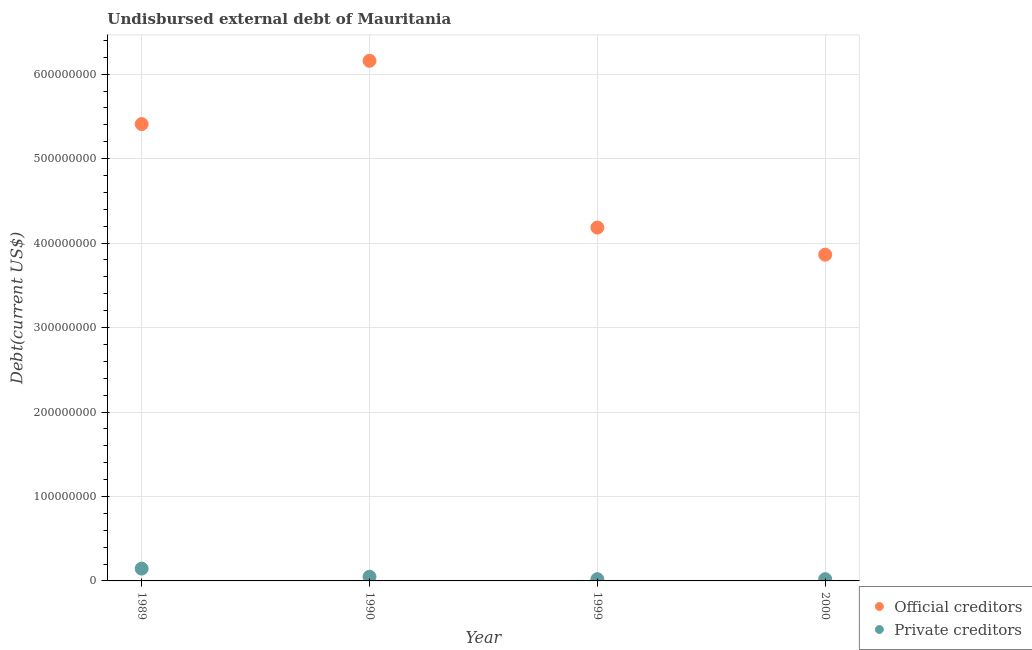Is the number of dotlines equal to the number of legend labels?
Your response must be concise. Yes. What is the undisbursed external debt of private creditors in 1989?
Provide a succinct answer. 1.46e+07. Across all years, what is the maximum undisbursed external debt of official creditors?
Provide a short and direct response. 6.16e+08. Across all years, what is the minimum undisbursed external debt of private creditors?
Give a very brief answer. 2.08e+06. In which year was the undisbursed external debt of private creditors maximum?
Ensure brevity in your answer.  1989. In which year was the undisbursed external debt of official creditors minimum?
Your answer should be very brief. 2000. What is the total undisbursed external debt of official creditors in the graph?
Give a very brief answer. 1.96e+09. What is the difference between the undisbursed external debt of private creditors in 1999 and that in 2000?
Keep it short and to the point. 0. What is the difference between the undisbursed external debt of private creditors in 1999 and the undisbursed external debt of official creditors in 2000?
Your answer should be compact. -3.84e+08. What is the average undisbursed external debt of official creditors per year?
Make the answer very short. 4.90e+08. In the year 1989, what is the difference between the undisbursed external debt of official creditors and undisbursed external debt of private creditors?
Give a very brief answer. 5.26e+08. In how many years, is the undisbursed external debt of private creditors greater than 280000000 US$?
Your response must be concise. 0. What is the ratio of the undisbursed external debt of official creditors in 1989 to that in 1999?
Provide a succinct answer. 1.29. Is the difference between the undisbursed external debt of official creditors in 1989 and 2000 greater than the difference between the undisbursed external debt of private creditors in 1989 and 2000?
Make the answer very short. Yes. What is the difference between the highest and the second highest undisbursed external debt of official creditors?
Offer a terse response. 7.49e+07. What is the difference between the highest and the lowest undisbursed external debt of official creditors?
Make the answer very short. 2.30e+08. In how many years, is the undisbursed external debt of private creditors greater than the average undisbursed external debt of private creditors taken over all years?
Keep it short and to the point. 1. Is the sum of the undisbursed external debt of official creditors in 1989 and 1999 greater than the maximum undisbursed external debt of private creditors across all years?
Make the answer very short. Yes. Is the undisbursed external debt of official creditors strictly greater than the undisbursed external debt of private creditors over the years?
Your answer should be compact. Yes. How many years are there in the graph?
Your answer should be very brief. 4. What is the difference between two consecutive major ticks on the Y-axis?
Provide a short and direct response. 1.00e+08. Where does the legend appear in the graph?
Your answer should be very brief. Bottom right. What is the title of the graph?
Give a very brief answer. Undisbursed external debt of Mauritania. Does "Fertility rate" appear as one of the legend labels in the graph?
Your answer should be very brief. No. What is the label or title of the Y-axis?
Your answer should be compact. Debt(current US$). What is the Debt(current US$) in Official creditors in 1989?
Your answer should be very brief. 5.41e+08. What is the Debt(current US$) in Private creditors in 1989?
Keep it short and to the point. 1.46e+07. What is the Debt(current US$) in Official creditors in 1990?
Offer a terse response. 6.16e+08. What is the Debt(current US$) of Private creditors in 1990?
Provide a short and direct response. 4.95e+06. What is the Debt(current US$) of Official creditors in 1999?
Your answer should be very brief. 4.18e+08. What is the Debt(current US$) of Private creditors in 1999?
Your answer should be compact. 2.08e+06. What is the Debt(current US$) in Official creditors in 2000?
Offer a terse response. 3.86e+08. What is the Debt(current US$) in Private creditors in 2000?
Ensure brevity in your answer.  2.08e+06. Across all years, what is the maximum Debt(current US$) of Official creditors?
Your answer should be very brief. 6.16e+08. Across all years, what is the maximum Debt(current US$) in Private creditors?
Your answer should be compact. 1.46e+07. Across all years, what is the minimum Debt(current US$) of Official creditors?
Offer a very short reply. 3.86e+08. Across all years, what is the minimum Debt(current US$) in Private creditors?
Your answer should be compact. 2.08e+06. What is the total Debt(current US$) in Official creditors in the graph?
Your answer should be very brief. 1.96e+09. What is the total Debt(current US$) of Private creditors in the graph?
Your answer should be very brief. 2.37e+07. What is the difference between the Debt(current US$) of Official creditors in 1989 and that in 1990?
Ensure brevity in your answer.  -7.49e+07. What is the difference between the Debt(current US$) in Private creditors in 1989 and that in 1990?
Make the answer very short. 9.63e+06. What is the difference between the Debt(current US$) in Official creditors in 1989 and that in 1999?
Provide a succinct answer. 1.23e+08. What is the difference between the Debt(current US$) in Private creditors in 1989 and that in 1999?
Keep it short and to the point. 1.25e+07. What is the difference between the Debt(current US$) in Official creditors in 1989 and that in 2000?
Offer a very short reply. 1.55e+08. What is the difference between the Debt(current US$) of Private creditors in 1989 and that in 2000?
Provide a short and direct response. 1.25e+07. What is the difference between the Debt(current US$) in Official creditors in 1990 and that in 1999?
Make the answer very short. 1.97e+08. What is the difference between the Debt(current US$) of Private creditors in 1990 and that in 1999?
Your answer should be very brief. 2.86e+06. What is the difference between the Debt(current US$) in Official creditors in 1990 and that in 2000?
Make the answer very short. 2.30e+08. What is the difference between the Debt(current US$) of Private creditors in 1990 and that in 2000?
Provide a short and direct response. 2.86e+06. What is the difference between the Debt(current US$) in Official creditors in 1999 and that in 2000?
Give a very brief answer. 3.21e+07. What is the difference between the Debt(current US$) in Official creditors in 1989 and the Debt(current US$) in Private creditors in 1990?
Ensure brevity in your answer.  5.36e+08. What is the difference between the Debt(current US$) of Official creditors in 1989 and the Debt(current US$) of Private creditors in 1999?
Make the answer very short. 5.39e+08. What is the difference between the Debt(current US$) of Official creditors in 1989 and the Debt(current US$) of Private creditors in 2000?
Your response must be concise. 5.39e+08. What is the difference between the Debt(current US$) in Official creditors in 1990 and the Debt(current US$) in Private creditors in 1999?
Your response must be concise. 6.14e+08. What is the difference between the Debt(current US$) of Official creditors in 1990 and the Debt(current US$) of Private creditors in 2000?
Your answer should be very brief. 6.14e+08. What is the difference between the Debt(current US$) of Official creditors in 1999 and the Debt(current US$) of Private creditors in 2000?
Provide a short and direct response. 4.16e+08. What is the average Debt(current US$) in Official creditors per year?
Offer a very short reply. 4.90e+08. What is the average Debt(current US$) in Private creditors per year?
Give a very brief answer. 5.92e+06. In the year 1989, what is the difference between the Debt(current US$) of Official creditors and Debt(current US$) of Private creditors?
Your response must be concise. 5.26e+08. In the year 1990, what is the difference between the Debt(current US$) in Official creditors and Debt(current US$) in Private creditors?
Ensure brevity in your answer.  6.11e+08. In the year 1999, what is the difference between the Debt(current US$) in Official creditors and Debt(current US$) in Private creditors?
Provide a short and direct response. 4.16e+08. In the year 2000, what is the difference between the Debt(current US$) of Official creditors and Debt(current US$) of Private creditors?
Your answer should be compact. 3.84e+08. What is the ratio of the Debt(current US$) of Official creditors in 1989 to that in 1990?
Offer a very short reply. 0.88. What is the ratio of the Debt(current US$) of Private creditors in 1989 to that in 1990?
Offer a terse response. 2.95. What is the ratio of the Debt(current US$) of Official creditors in 1989 to that in 1999?
Provide a succinct answer. 1.29. What is the ratio of the Debt(current US$) in Private creditors in 1989 to that in 1999?
Give a very brief answer. 7. What is the ratio of the Debt(current US$) in Official creditors in 1989 to that in 2000?
Provide a succinct answer. 1.4. What is the ratio of the Debt(current US$) of Private creditors in 1989 to that in 2000?
Your response must be concise. 7. What is the ratio of the Debt(current US$) in Official creditors in 1990 to that in 1999?
Offer a terse response. 1.47. What is the ratio of the Debt(current US$) in Private creditors in 1990 to that in 1999?
Your answer should be compact. 2.38. What is the ratio of the Debt(current US$) of Official creditors in 1990 to that in 2000?
Your answer should be very brief. 1.59. What is the ratio of the Debt(current US$) of Private creditors in 1990 to that in 2000?
Make the answer very short. 2.38. What is the ratio of the Debt(current US$) of Official creditors in 1999 to that in 2000?
Provide a succinct answer. 1.08. What is the ratio of the Debt(current US$) of Private creditors in 1999 to that in 2000?
Give a very brief answer. 1. What is the difference between the highest and the second highest Debt(current US$) of Official creditors?
Your answer should be compact. 7.49e+07. What is the difference between the highest and the second highest Debt(current US$) in Private creditors?
Give a very brief answer. 9.63e+06. What is the difference between the highest and the lowest Debt(current US$) in Official creditors?
Keep it short and to the point. 2.30e+08. What is the difference between the highest and the lowest Debt(current US$) in Private creditors?
Offer a terse response. 1.25e+07. 